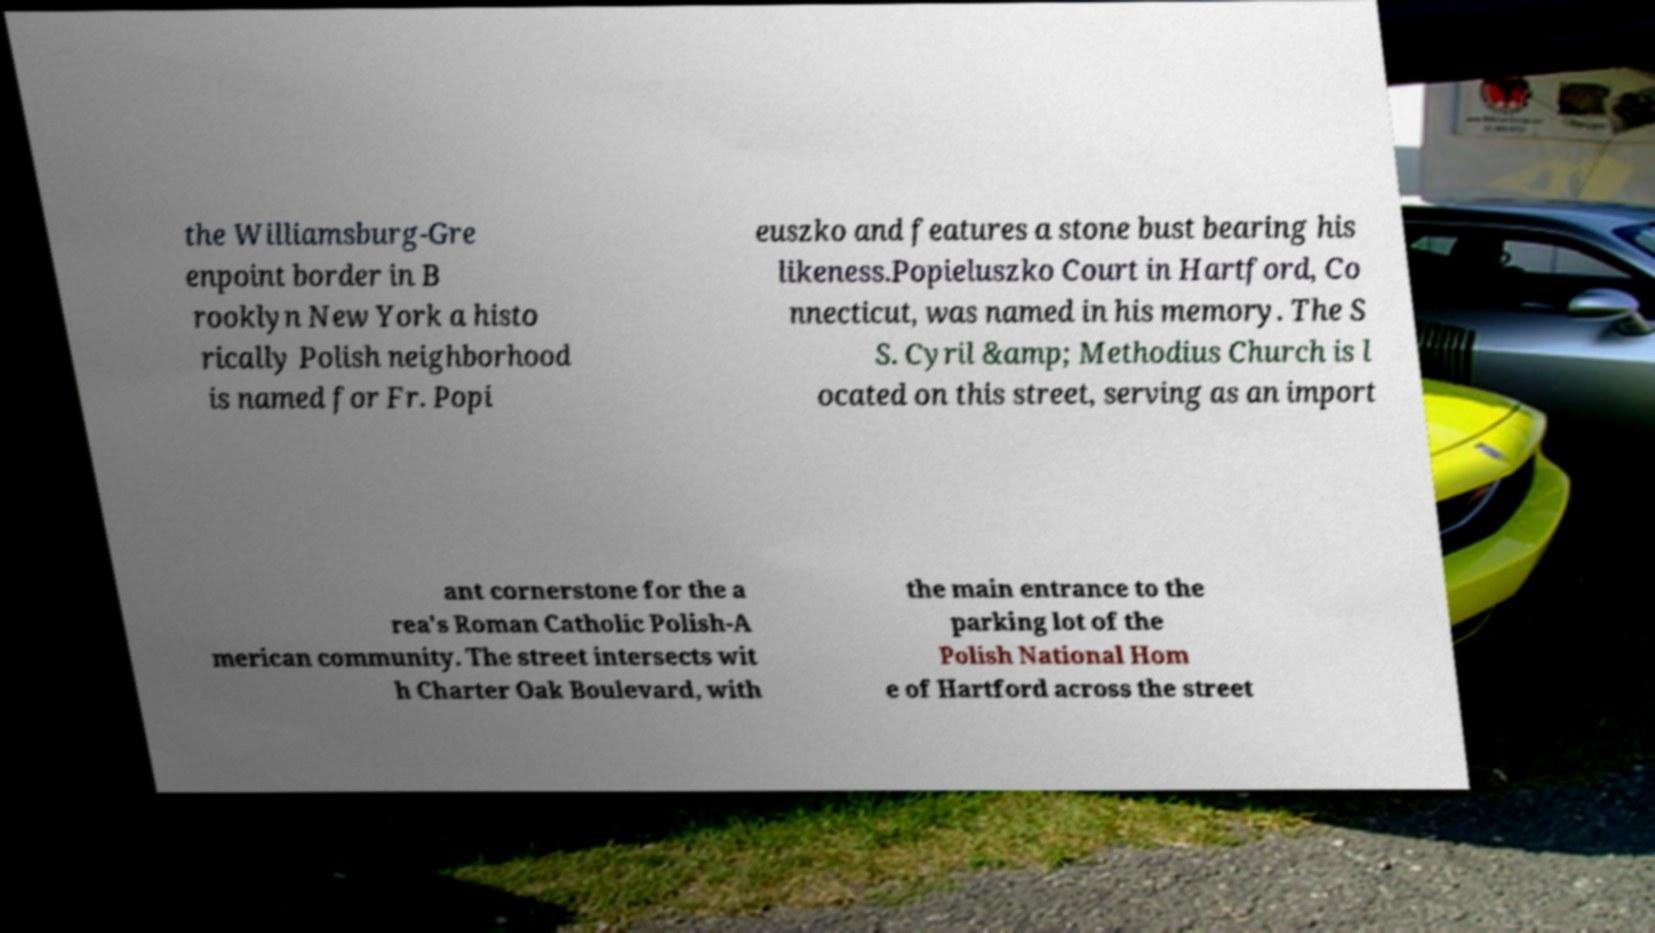Can you read and provide the text displayed in the image?This photo seems to have some interesting text. Can you extract and type it out for me? the Williamsburg-Gre enpoint border in B rooklyn New York a histo rically Polish neighborhood is named for Fr. Popi euszko and features a stone bust bearing his likeness.Popieluszko Court in Hartford, Co nnecticut, was named in his memory. The S S. Cyril &amp; Methodius Church is l ocated on this street, serving as an import ant cornerstone for the a rea's Roman Catholic Polish-A merican community. The street intersects wit h Charter Oak Boulevard, with the main entrance to the parking lot of the Polish National Hom e of Hartford across the street 